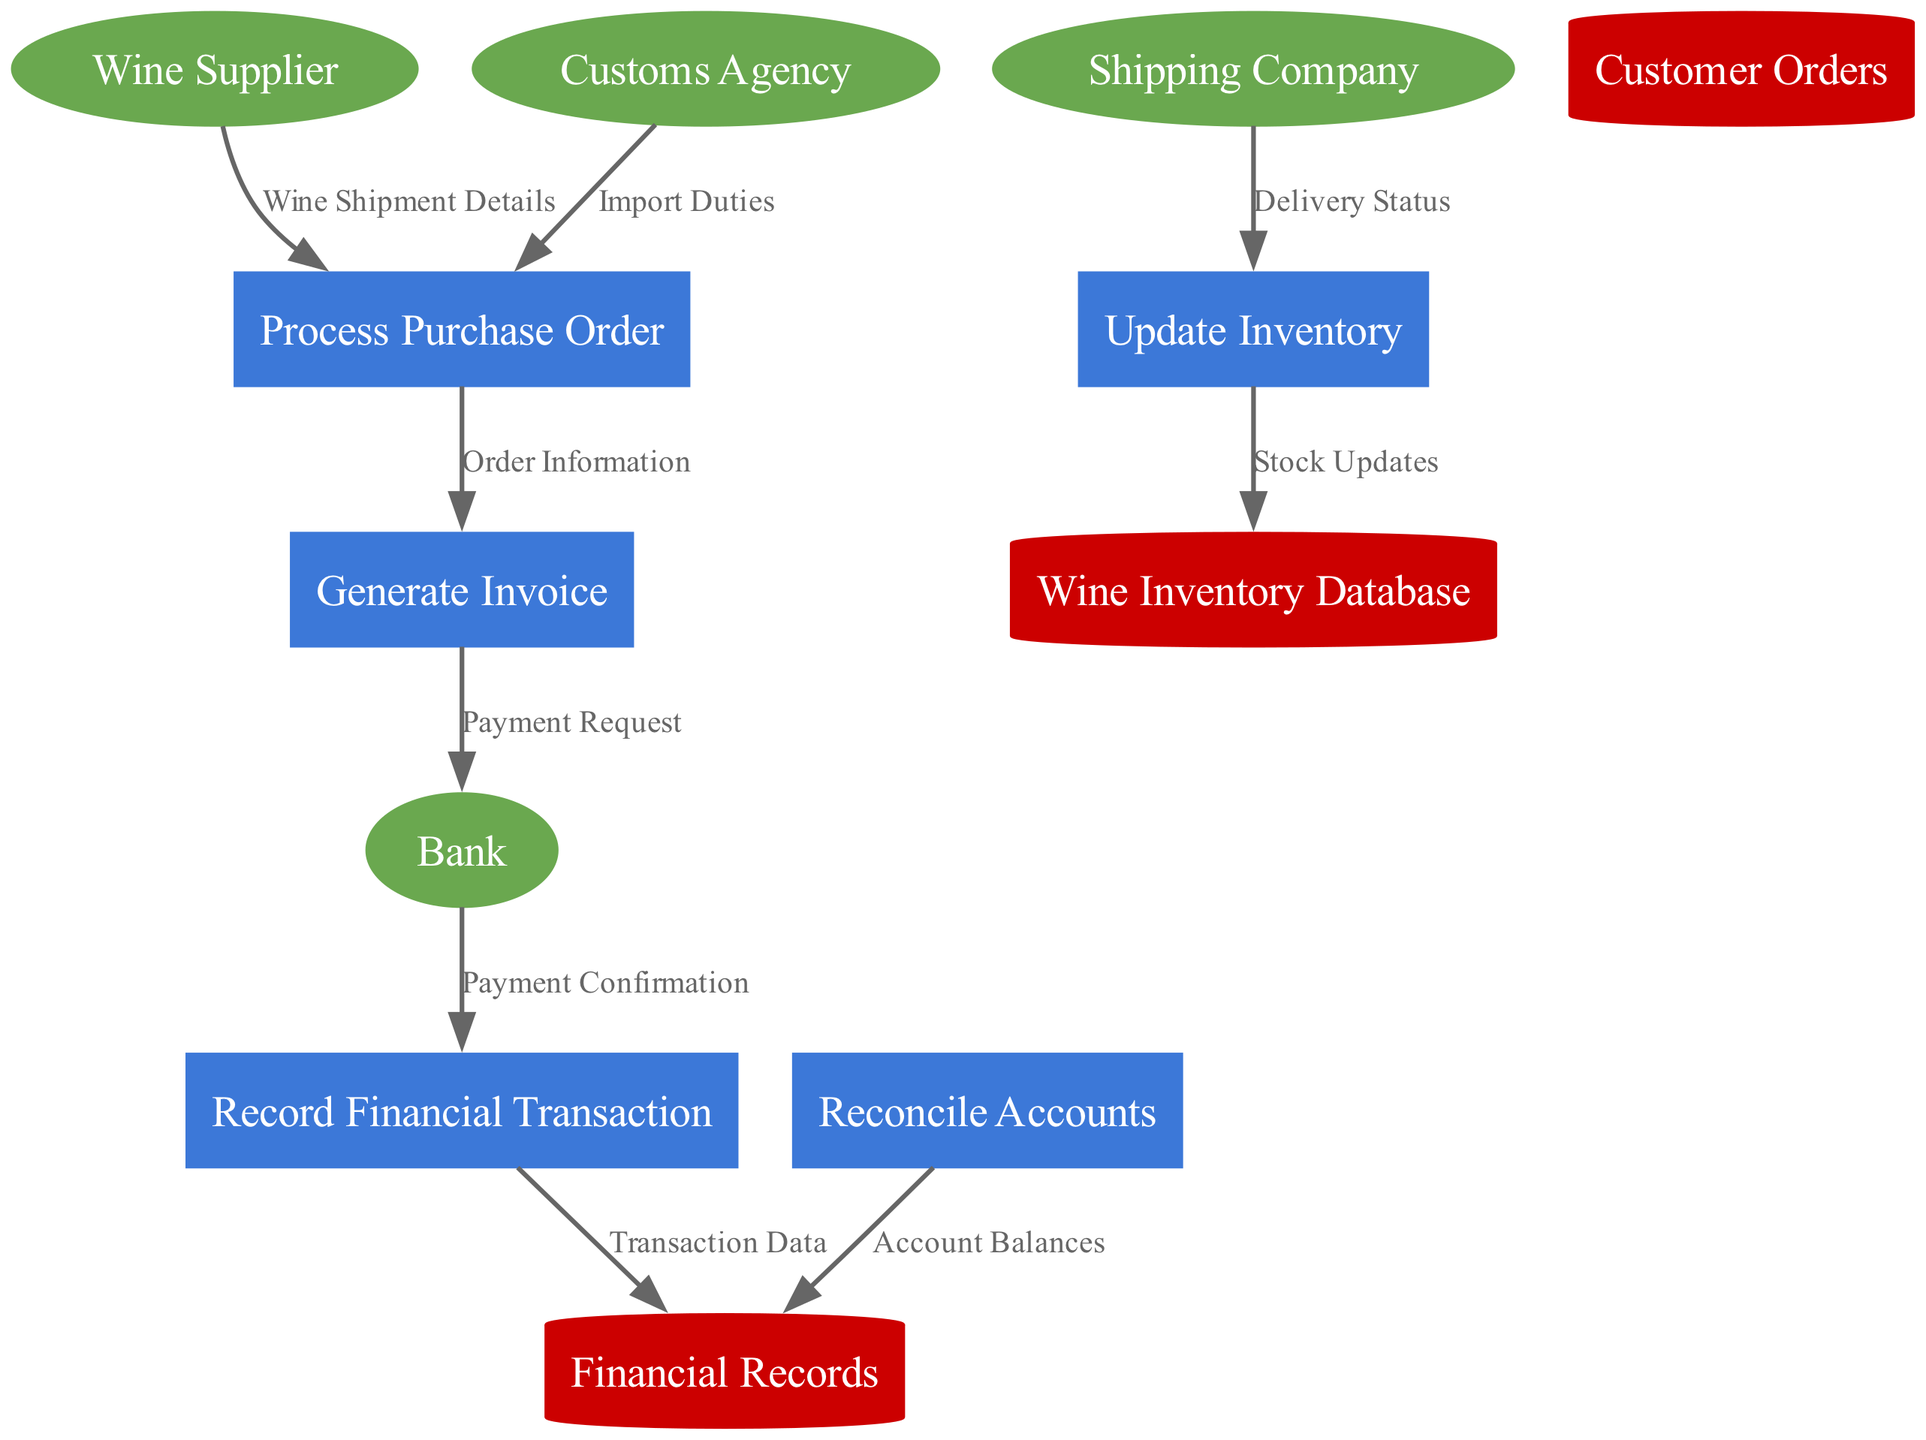What are the external entities in this diagram? The external entities are listed at the beginning of the diagram: Wine Supplier, Customs Agency, Bank, and Shipping Company.
Answer: Wine Supplier, Customs Agency, Bank, Shipping Company How many processes are involved in the order processing system? The diagram lists five distinct processes: Process Purchase Order, Generate Invoice, Update Inventory, Record Financial Transaction, and Reconcile Accounts. By counting these, we confirm there are five processes.
Answer: five What is the label for the data flow from the Wine Supplier to Process Purchase Order? The data flow from Wine Supplier to Process Purchase Order is labeled "Wine Shipment Details" in the diagram.
Answer: Wine Shipment Details Which data store receives data from Update Inventory? The Update Inventory process sends data to the Wine Inventory Database, as indicated by the arrow pointing towards it.
Answer: Wine Inventory Database How does the payment confirmation reach the financial records store? The payment confirmation flows from the Bank to Record Financial Transaction, which then sends Transaction Data to the Financial Records, creating a chain from Bank to Financial Records.
Answer: Financial Records What is the relationship between Generate Invoice and Bank? The Generate Invoice process sends a Payment Request to the Bank, from which a Payment Confirmation is later received, representing a direct relationship between these two entities.
Answer: Payment Request How many external entities are there that interact with the processes in the diagram? The diagram identifies four external entities: Wine Supplier, Customs Agency, Bank, and Shipping Company, hence the total is four.
Answer: four Which process updates the inventory based on the delivery status? The process that updates the inventory is Update Inventory, which receives the Delivery Status from the Shipping Company.
Answer: Update Inventory What type of data store is Financial Records? The Financial Records is categorized as a data store in the diagram, represented by a cylinder shape.
Answer: cylinder 